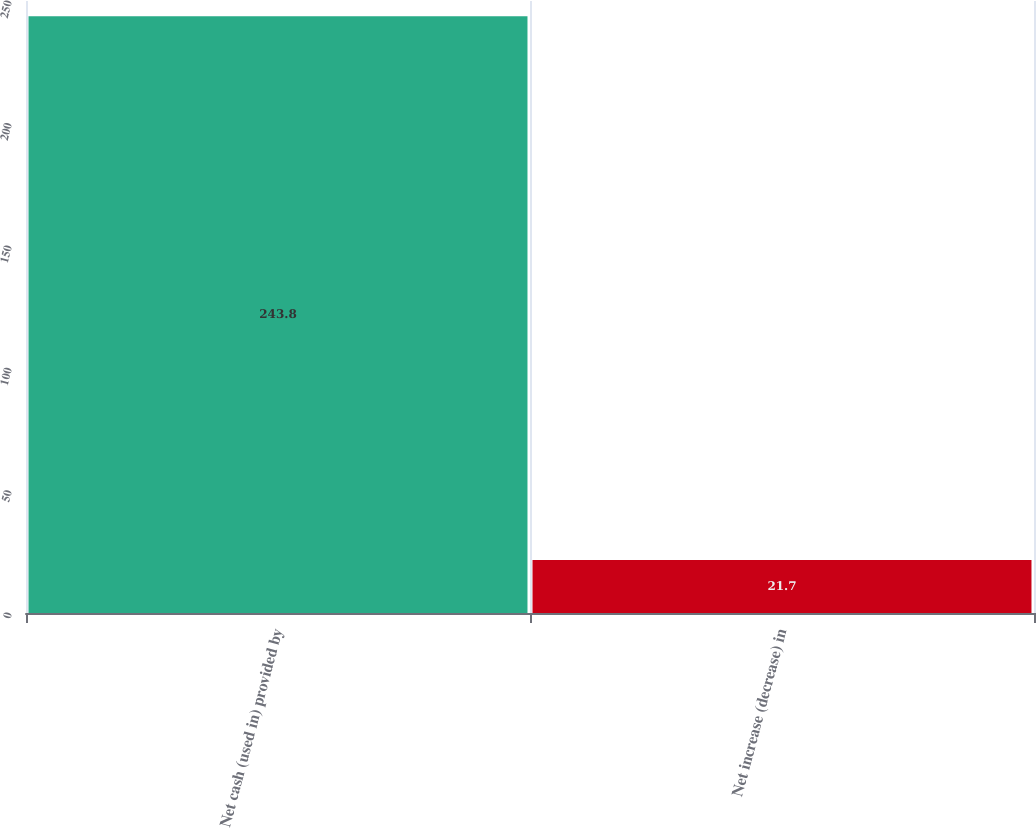Convert chart to OTSL. <chart><loc_0><loc_0><loc_500><loc_500><bar_chart><fcel>Net cash (used in) provided by<fcel>Net increase (decrease) in<nl><fcel>243.8<fcel>21.7<nl></chart> 